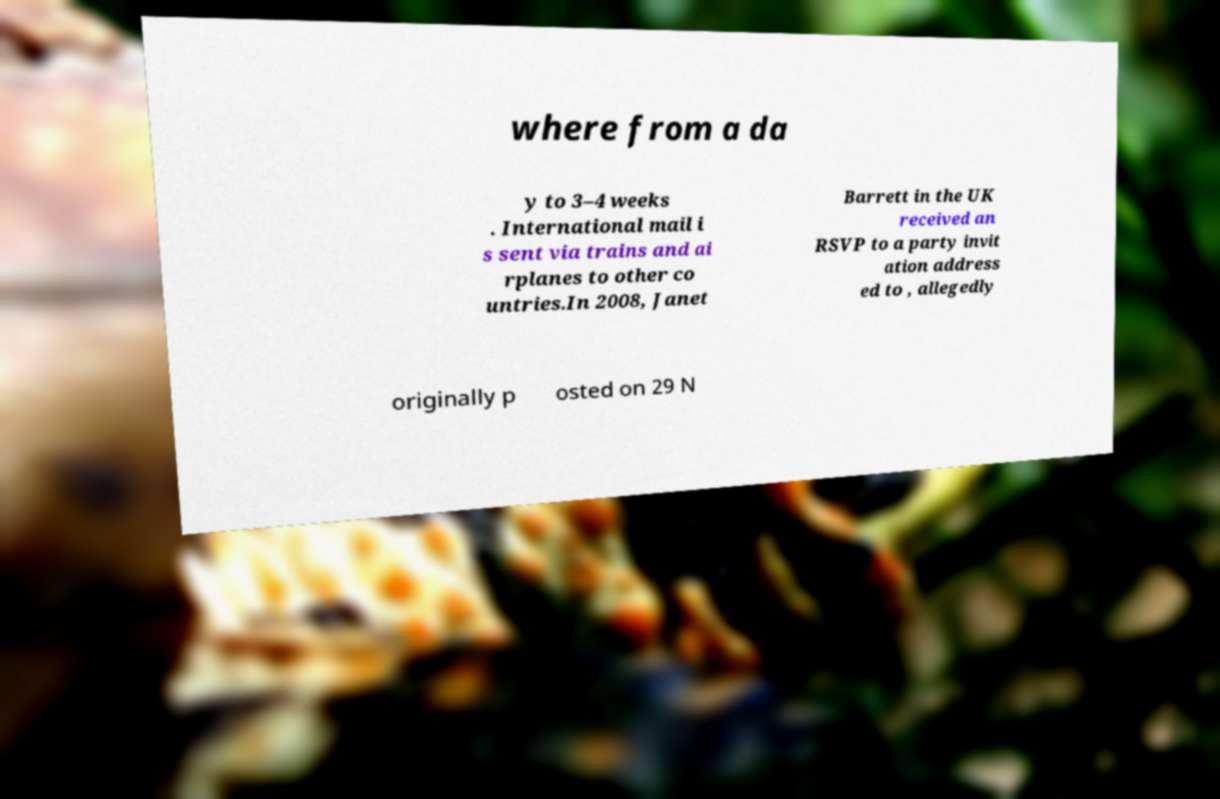Please identify and transcribe the text found in this image. where from a da y to 3–4 weeks . International mail i s sent via trains and ai rplanes to other co untries.In 2008, Janet Barrett in the UK received an RSVP to a party invit ation address ed to , allegedly originally p osted on 29 N 